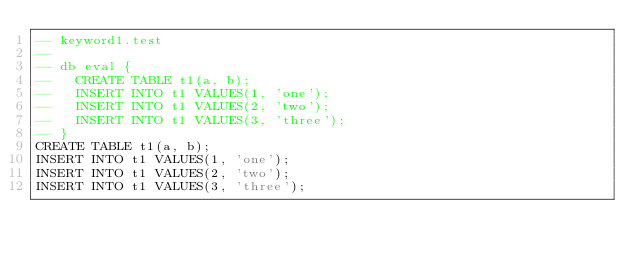Convert code to text. <code><loc_0><loc_0><loc_500><loc_500><_SQL_>-- keyword1.test
-- 
-- db eval {
--   CREATE TABLE t1(a, b);
--   INSERT INTO t1 VALUES(1, 'one');
--   INSERT INTO t1 VALUES(2, 'two');
--   INSERT INTO t1 VALUES(3, 'three');
-- }
CREATE TABLE t1(a, b);
INSERT INTO t1 VALUES(1, 'one');
INSERT INTO t1 VALUES(2, 'two');
INSERT INTO t1 VALUES(3, 'three');</code> 